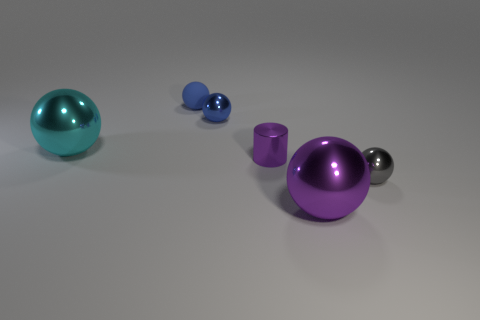What number of cyan objects are there?
Make the answer very short. 1. There is a shiny sphere that is both left of the gray sphere and in front of the cylinder; how big is it?
Offer a terse response. Large. There is a blue matte object that is the same size as the shiny cylinder; what is its shape?
Ensure brevity in your answer.  Sphere. Is there a tiny gray metal object on the left side of the large purple ball that is in front of the tiny blue matte object?
Give a very brief answer. No. There is another large object that is the same shape as the cyan object; what is its color?
Your answer should be very brief. Purple. Does the large sphere right of the cyan sphere have the same color as the cylinder?
Your response must be concise. Yes. How many things are either small metal things that are to the left of the metallic cylinder or cyan spheres?
Keep it short and to the point. 2. There is a big sphere that is behind the gray object in front of the tiny metallic sphere behind the cyan metal sphere; what is its material?
Offer a very short reply. Metal. Is the number of big spheres in front of the blue matte sphere greater than the number of objects in front of the small gray object?
Offer a terse response. Yes. What number of spheres are either green metal things or small blue metallic things?
Your answer should be compact. 1. 